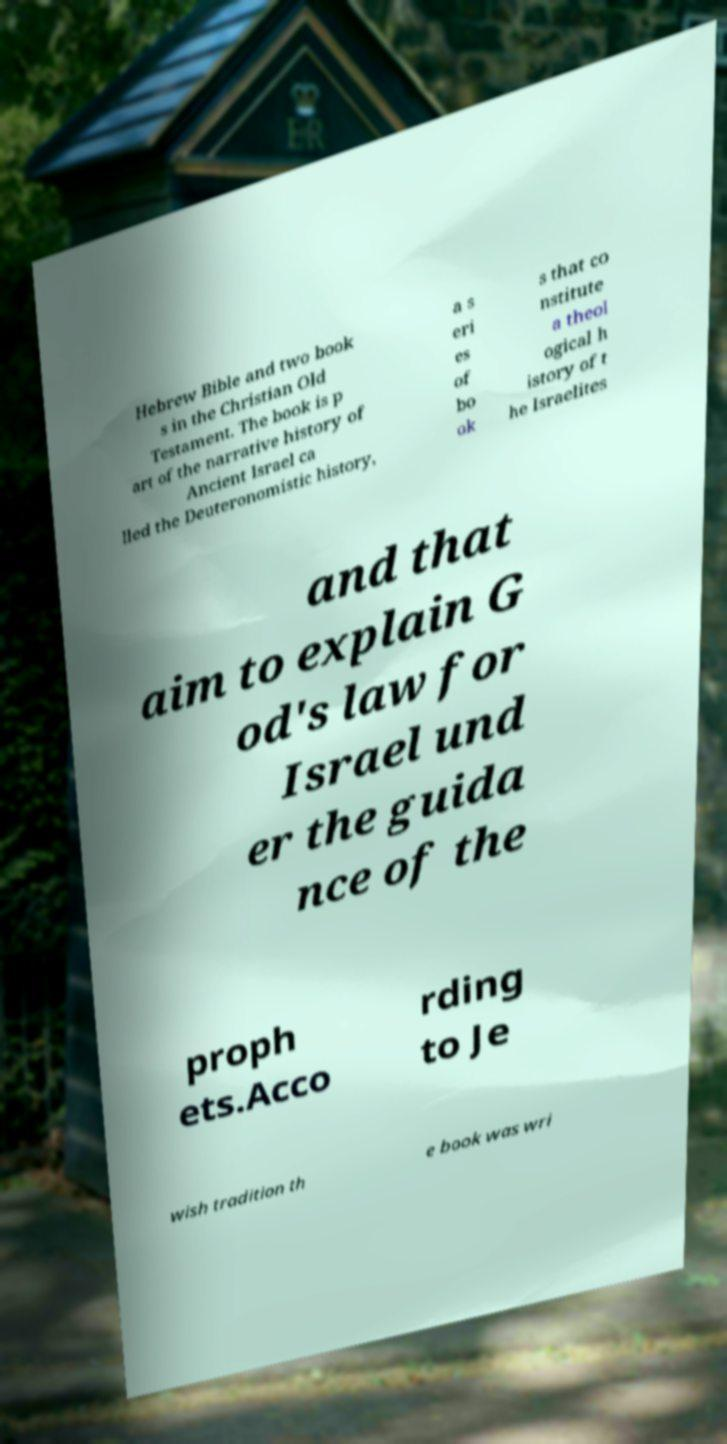Please identify and transcribe the text found in this image. Hebrew Bible and two book s in the Christian Old Testament. The book is p art of the narrative history of Ancient Israel ca lled the Deuteronomistic history, a s eri es of bo ok s that co nstitute a theol ogical h istory of t he Israelites and that aim to explain G od's law for Israel und er the guida nce of the proph ets.Acco rding to Je wish tradition th e book was wri 